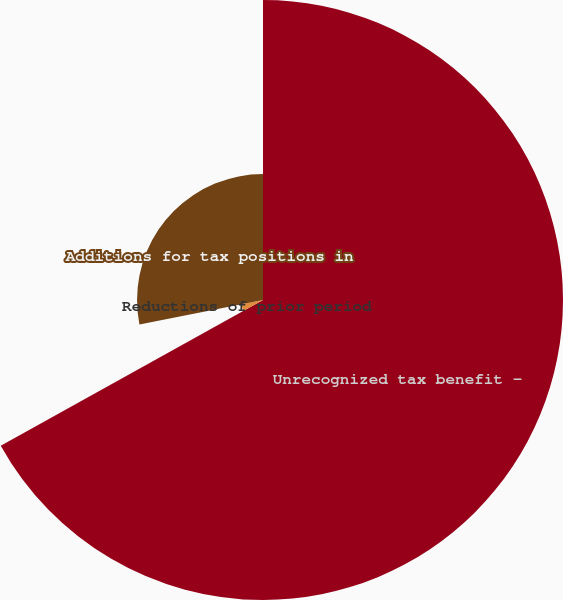<chart> <loc_0><loc_0><loc_500><loc_500><pie_chart><fcel>Unrecognized tax benefit -<fcel>Reductions of prior period<fcel>Additions for tax positions in<nl><fcel>66.93%<fcel>4.97%<fcel>28.1%<nl></chart> 